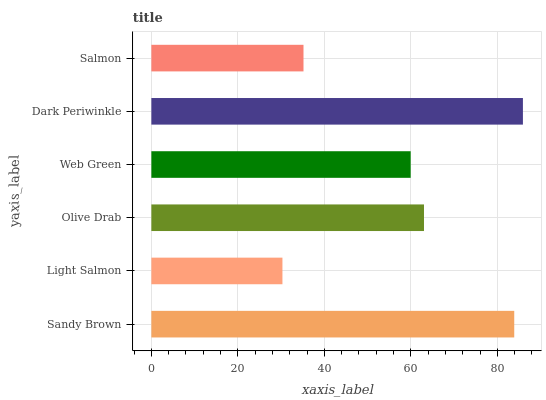Is Light Salmon the minimum?
Answer yes or no. Yes. Is Dark Periwinkle the maximum?
Answer yes or no. Yes. Is Olive Drab the minimum?
Answer yes or no. No. Is Olive Drab the maximum?
Answer yes or no. No. Is Olive Drab greater than Light Salmon?
Answer yes or no. Yes. Is Light Salmon less than Olive Drab?
Answer yes or no. Yes. Is Light Salmon greater than Olive Drab?
Answer yes or no. No. Is Olive Drab less than Light Salmon?
Answer yes or no. No. Is Olive Drab the high median?
Answer yes or no. Yes. Is Web Green the low median?
Answer yes or no. Yes. Is Salmon the high median?
Answer yes or no. No. Is Olive Drab the low median?
Answer yes or no. No. 